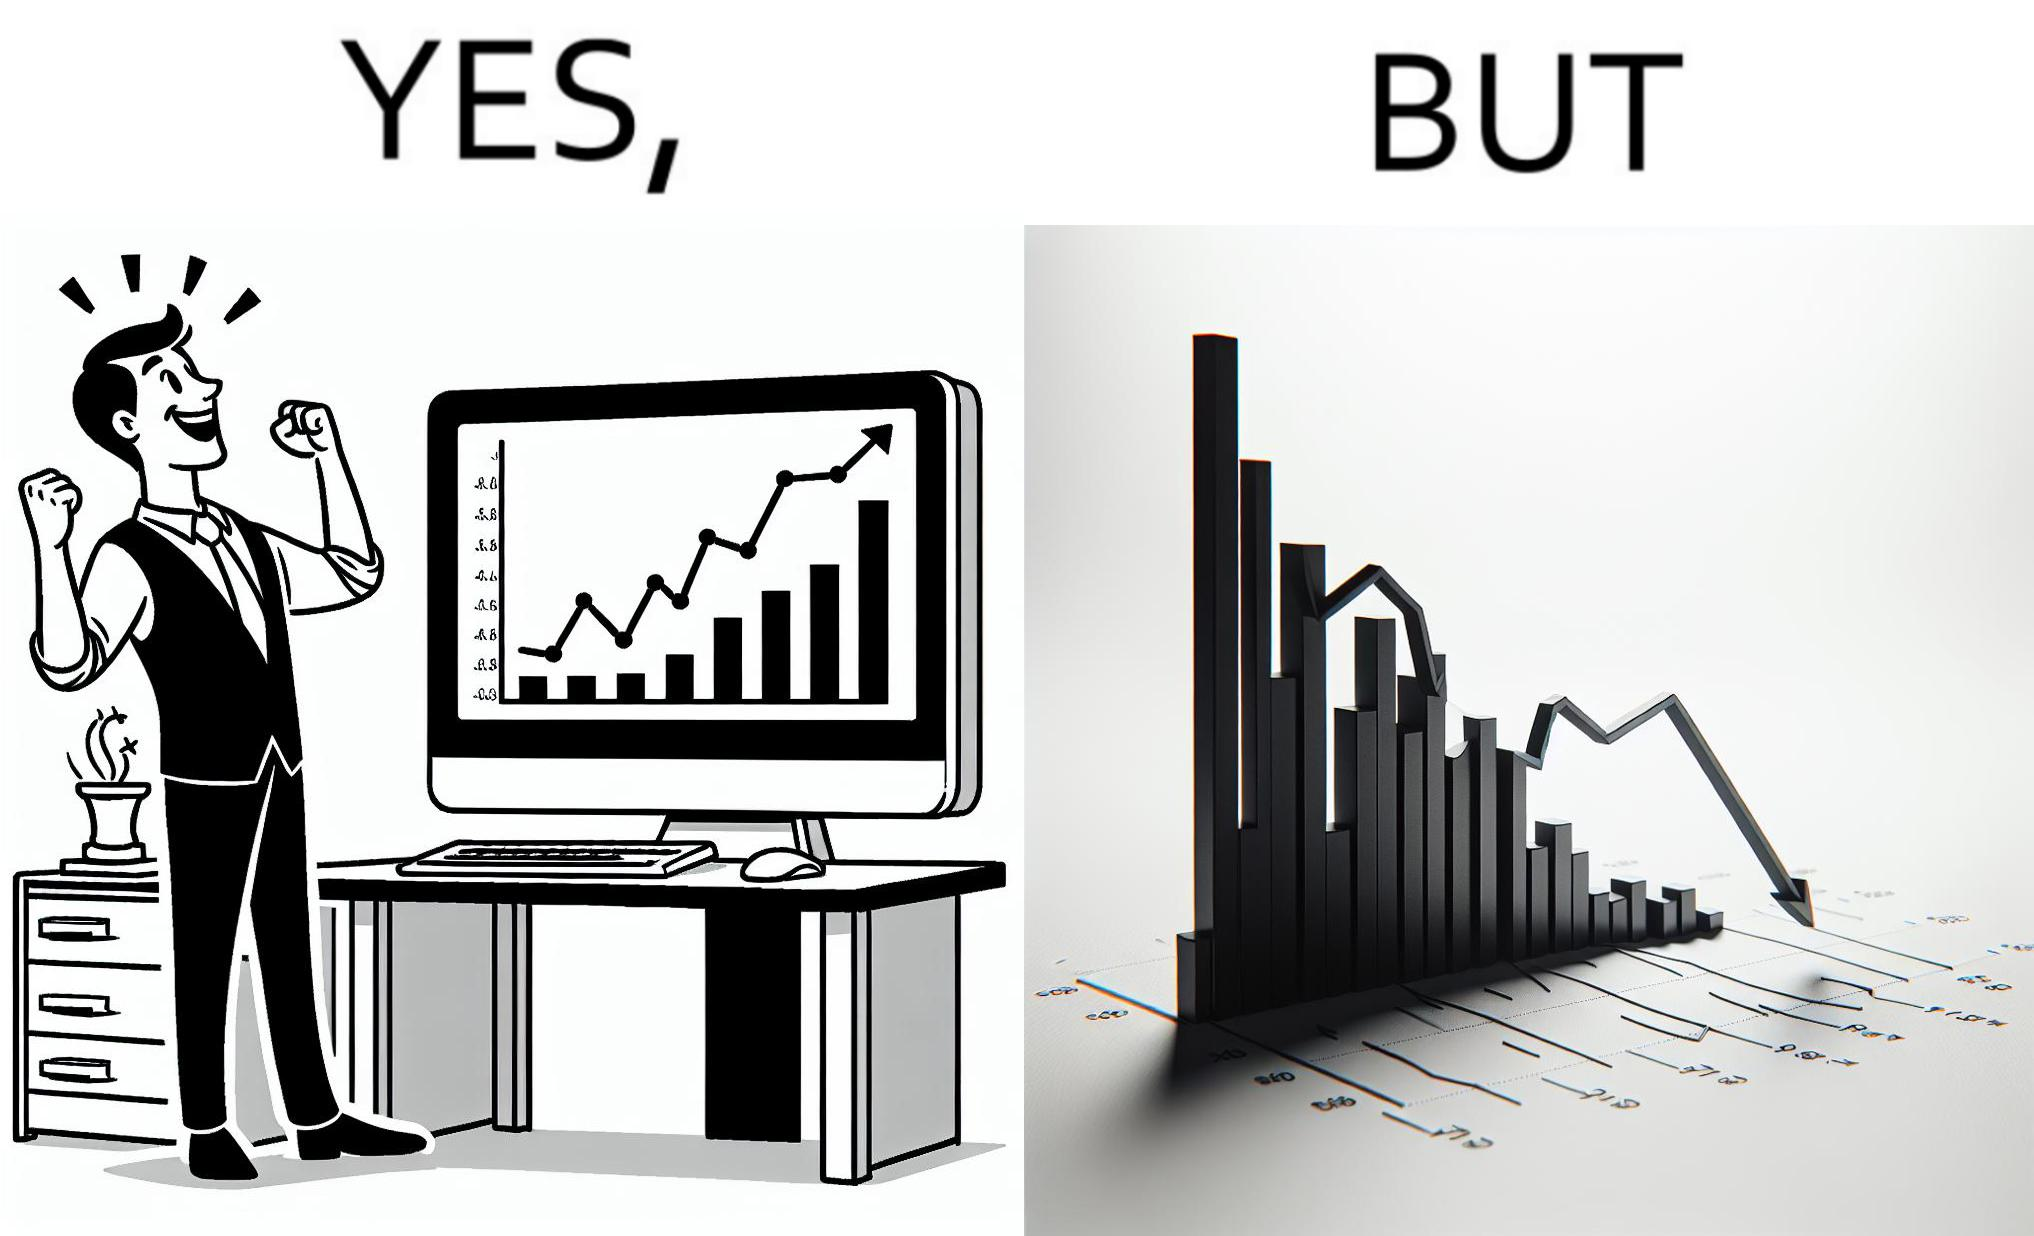Is there satirical content in this image? Yes, this image is satirical. 